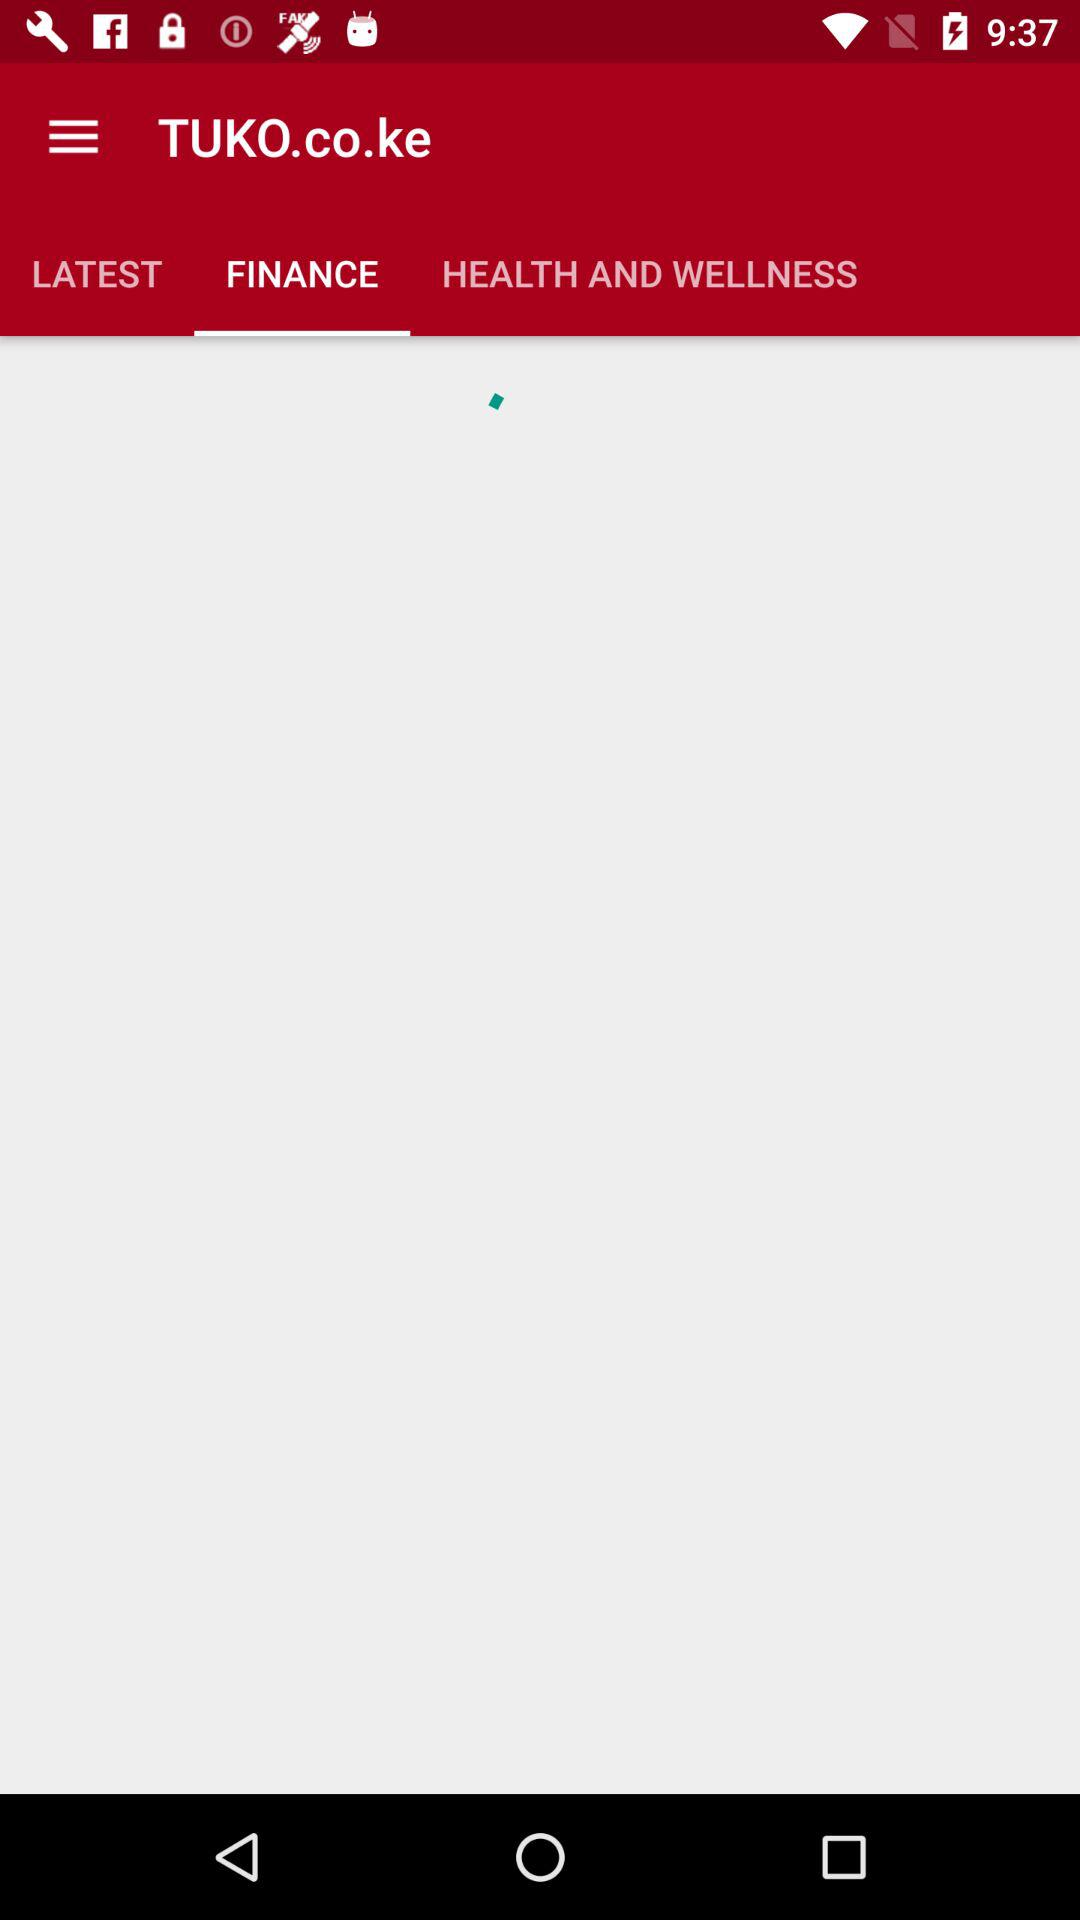What is the name of the application? The name of the application is "TUKO.co.ke". 